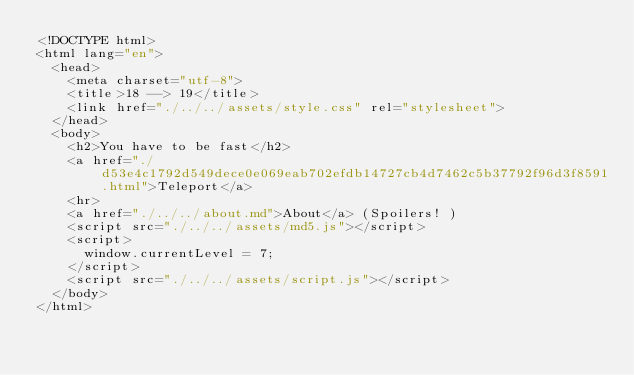Convert code to text. <code><loc_0><loc_0><loc_500><loc_500><_HTML_><!DOCTYPE html>
<html lang="en">
  <head>
    <meta charset="utf-8">
    <title>18 --> 19</title>
    <link href="./../../assets/style.css" rel="stylesheet">
  </head>
  <body>
    <h2>You have to be fast</h2>
    <a href="./d53e4c1792d549dece0e069eab702efdb14727cb4d7462c5b37792f96d3f8591.html">Teleport</a>
    <hr>
    <a href="./../../about.md">About</a> (Spoilers! )
    <script src="./../../assets/md5.js"></script>
    <script>
      window.currentLevel = 7;
    </script>
    <script src="./../../assets/script.js"></script>
  </body>
</html></code> 